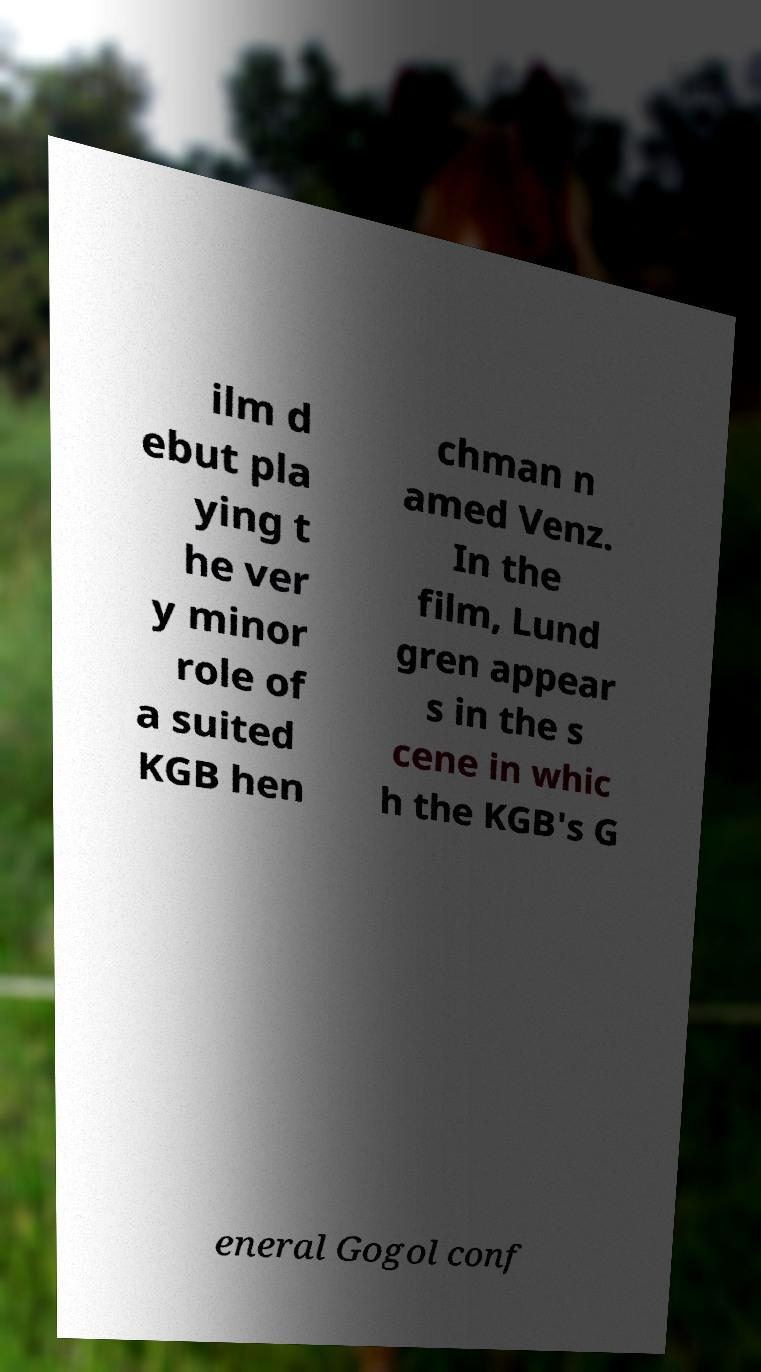For documentation purposes, I need the text within this image transcribed. Could you provide that? ilm d ebut pla ying t he ver y minor role of a suited KGB hen chman n amed Venz. In the film, Lund gren appear s in the s cene in whic h the KGB's G eneral Gogol conf 